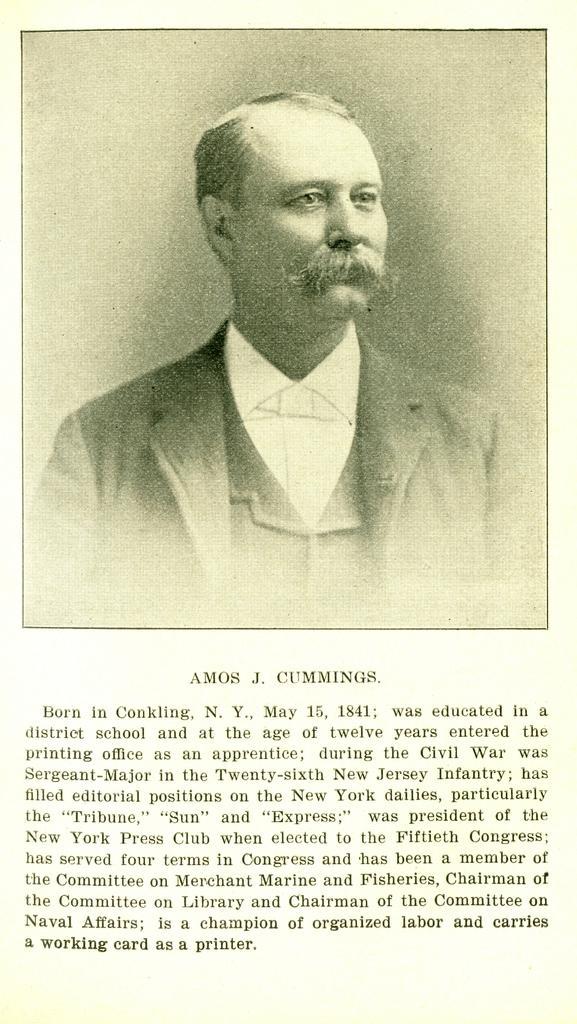Please provide a concise description of this image. In this picture I can see there is a photo graph of the man and he is looking at the right side and there is a wall and there is something written here in the bottom. 